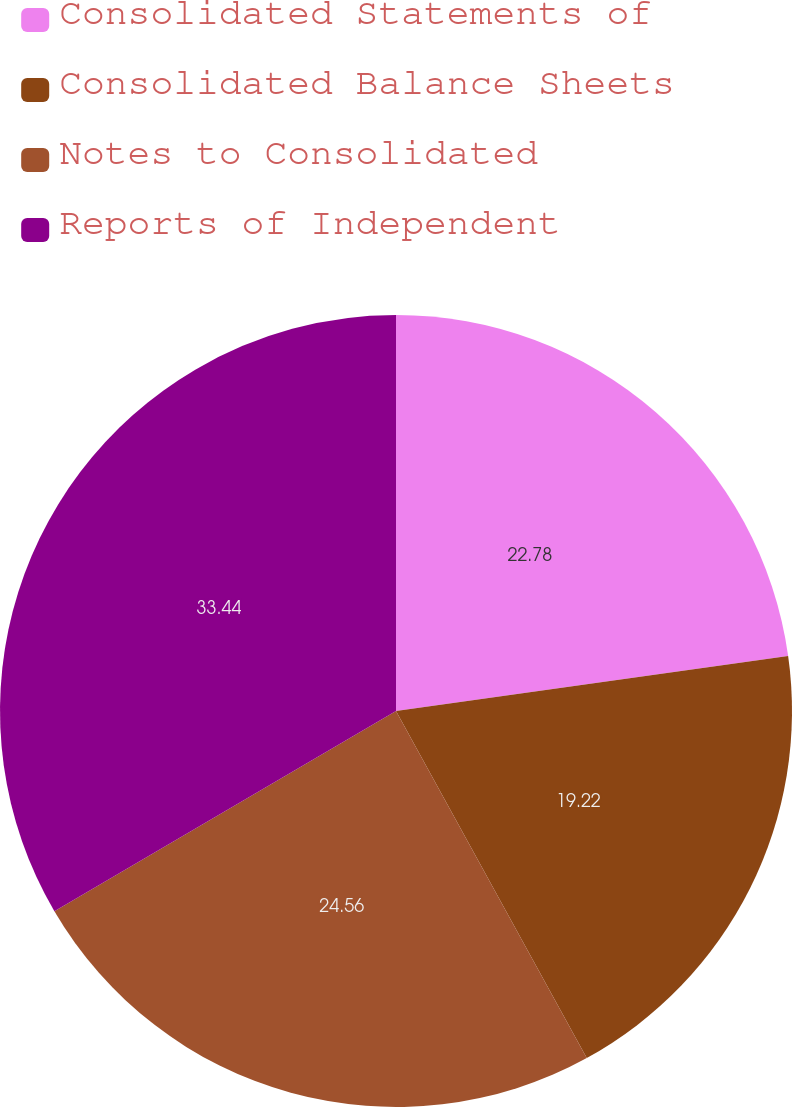<chart> <loc_0><loc_0><loc_500><loc_500><pie_chart><fcel>Consolidated Statements of<fcel>Consolidated Balance Sheets<fcel>Notes to Consolidated<fcel>Reports of Independent<nl><fcel>22.78%<fcel>19.22%<fcel>24.56%<fcel>33.44%<nl></chart> 